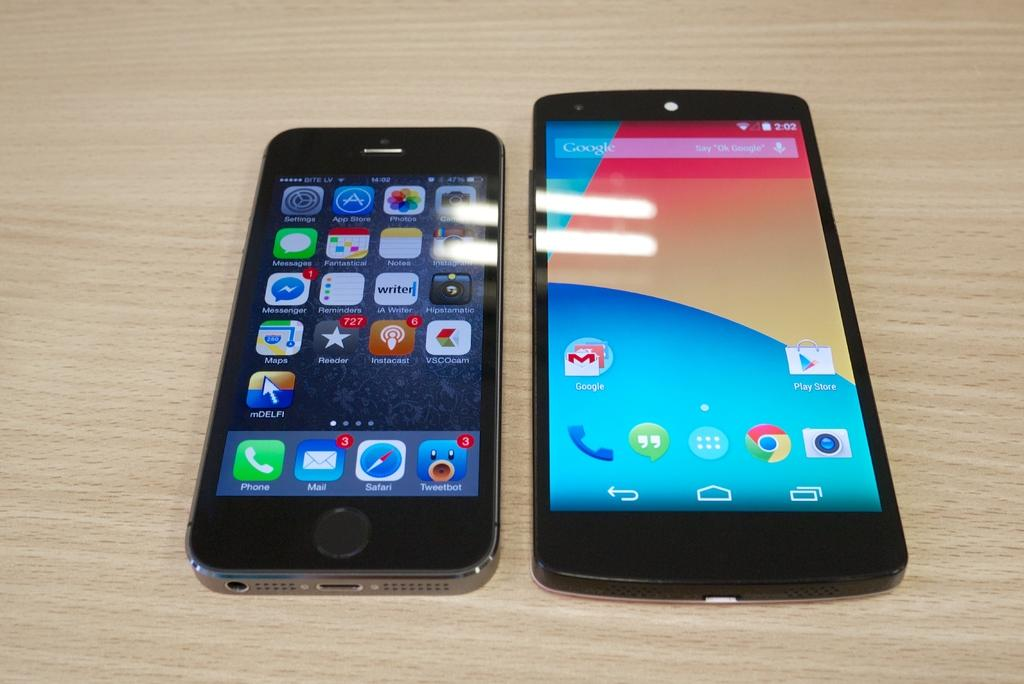Provide a one-sentence caption for the provided image. Two phones, one being an iPhone (on the left) and the other being an Android phone (on the right). 